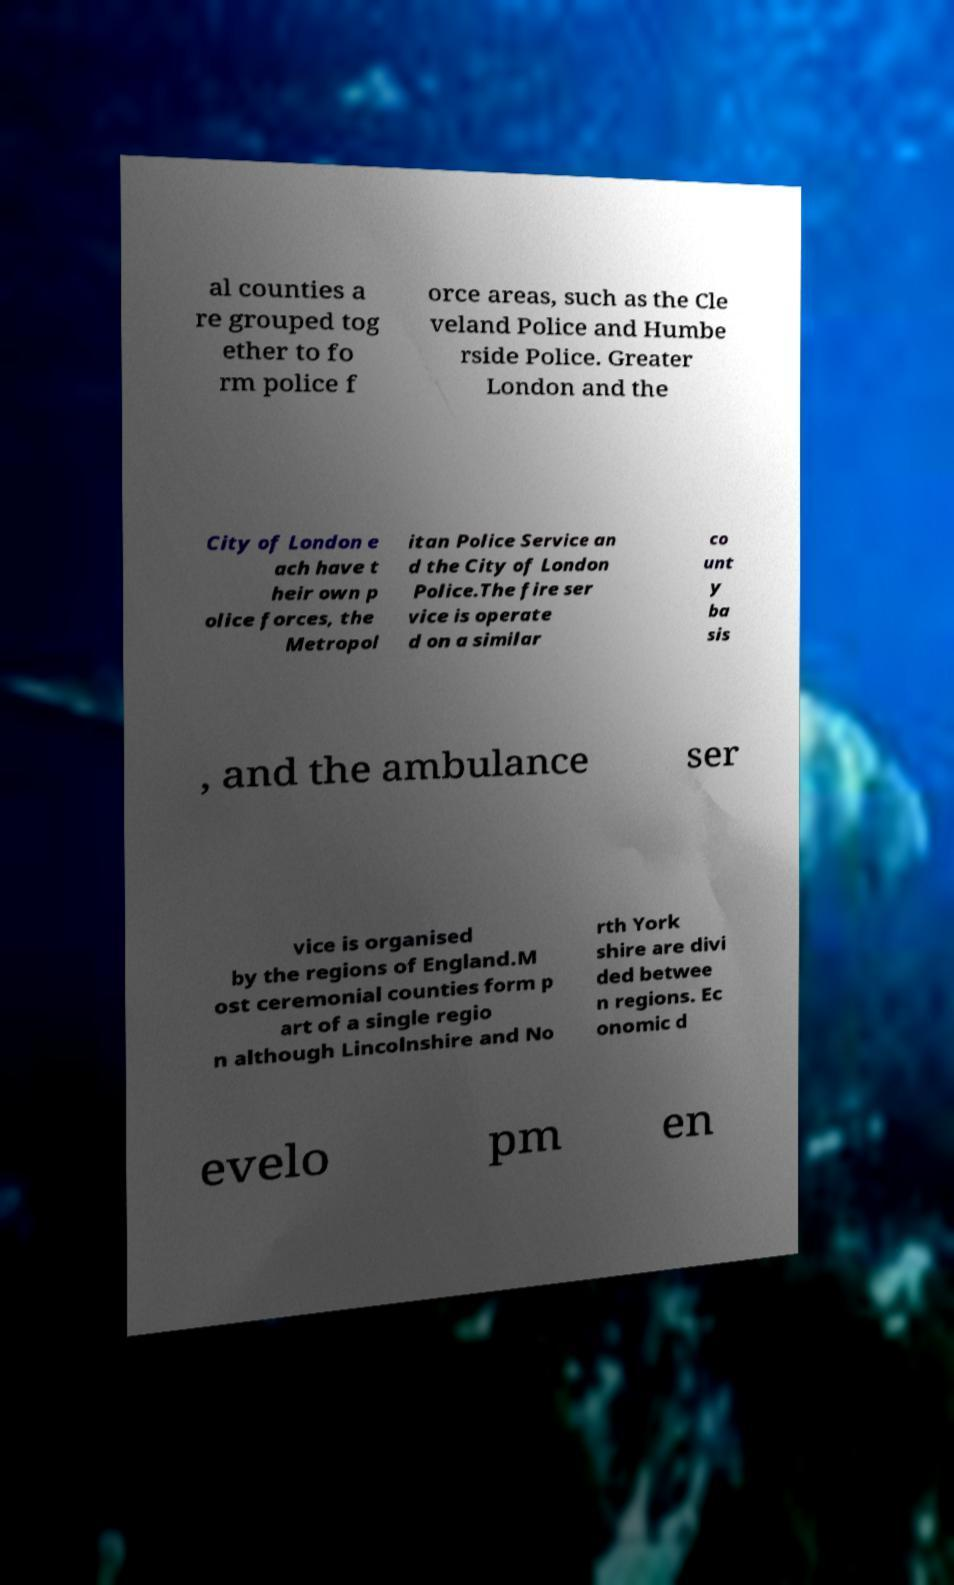What messages or text are displayed in this image? I need them in a readable, typed format. al counties a re grouped tog ether to fo rm police f orce areas, such as the Cle veland Police and Humbe rside Police. Greater London and the City of London e ach have t heir own p olice forces, the Metropol itan Police Service an d the City of London Police.The fire ser vice is operate d on a similar co unt y ba sis , and the ambulance ser vice is organised by the regions of England.M ost ceremonial counties form p art of a single regio n although Lincolnshire and No rth York shire are divi ded betwee n regions. Ec onomic d evelo pm en 